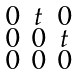Convert formula to latex. <formula><loc_0><loc_0><loc_500><loc_500>\begin{smallmatrix} 0 & t & 0 \\ 0 & 0 & t \\ 0 & 0 & 0 \end{smallmatrix}</formula> 